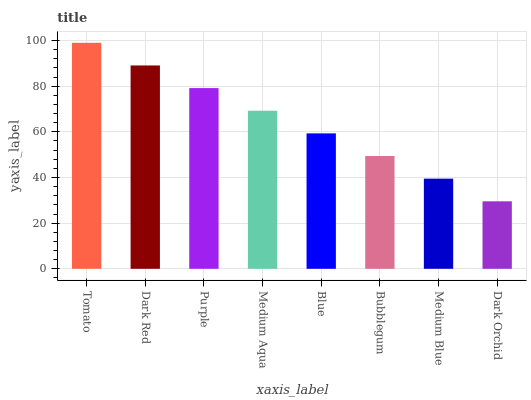Is Dark Orchid the minimum?
Answer yes or no. Yes. Is Tomato the maximum?
Answer yes or no. Yes. Is Dark Red the minimum?
Answer yes or no. No. Is Dark Red the maximum?
Answer yes or no. No. Is Tomato greater than Dark Red?
Answer yes or no. Yes. Is Dark Red less than Tomato?
Answer yes or no. Yes. Is Dark Red greater than Tomato?
Answer yes or no. No. Is Tomato less than Dark Red?
Answer yes or no. No. Is Medium Aqua the high median?
Answer yes or no. Yes. Is Blue the low median?
Answer yes or no. Yes. Is Dark Red the high median?
Answer yes or no. No. Is Medium Blue the low median?
Answer yes or no. No. 